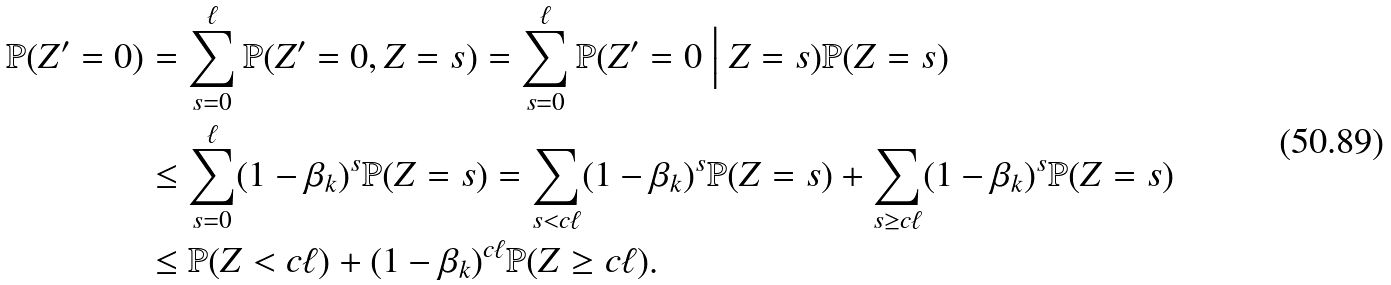<formula> <loc_0><loc_0><loc_500><loc_500>\mathbb { P } ( Z ^ { \prime } = 0 ) & = \sum _ { s = 0 } ^ { \ell } \mathbb { P } ( Z ^ { \prime } = 0 , Z = s ) = \sum _ { s = 0 } ^ { \ell } \mathbb { P } ( Z ^ { \prime } = 0 \ \Big | \ Z = s ) \mathbb { P } ( Z = s ) \\ & \leq \sum _ { s = 0 } ^ { \ell } ( 1 - \beta _ { k } ) ^ { s } \mathbb { P } ( Z = s ) = \sum _ { s < c \ell } ( 1 - \beta _ { k } ) ^ { s } \mathbb { P } ( Z = s ) + \sum _ { s \geq c \ell } ( 1 - \beta _ { k } ) ^ { s } \mathbb { P } ( Z = s ) \\ & \leq \mathbb { P } ( Z < c \ell ) + ( 1 - \beta _ { k } ) ^ { c \ell } \mathbb { P } ( Z \geq c \ell ) .</formula> 